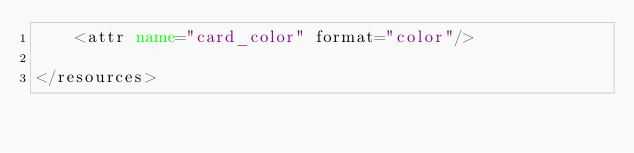Convert code to text. <code><loc_0><loc_0><loc_500><loc_500><_XML_>    <attr name="card_color" format="color"/>

</resources></code> 